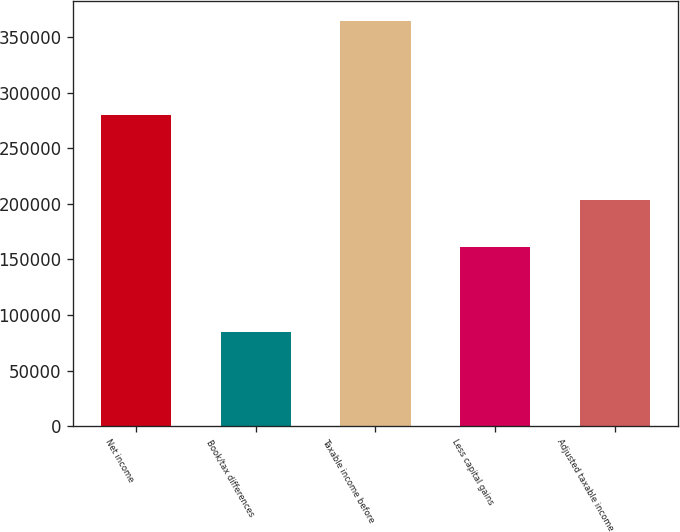<chart> <loc_0><loc_0><loc_500><loc_500><bar_chart><fcel>Net income<fcel>Book/tax differences<fcel>Taxable income before<fcel>Less capital gains<fcel>Adjusted taxable income<nl><fcel>279467<fcel>84914<fcel>364381<fcel>160797<fcel>203584<nl></chart> 